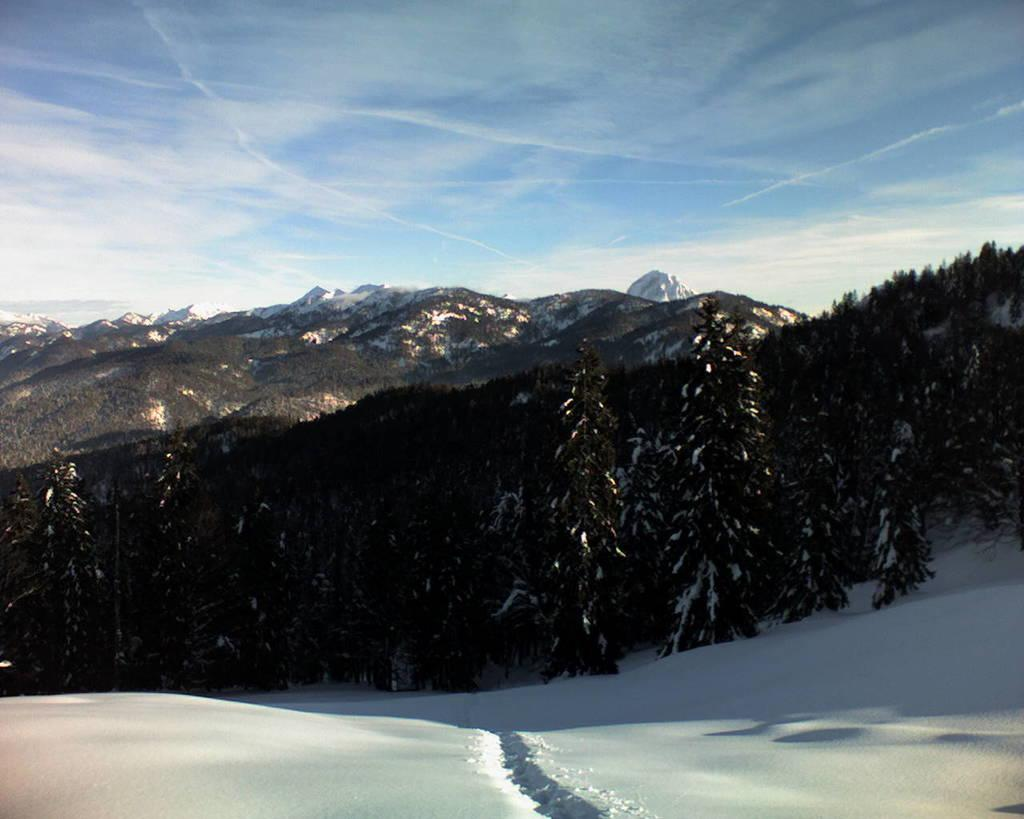What type of weather condition is depicted in the image? There is snow in the image, indicating a cold and wintry scene. What natural elements can be seen in the image? There are trees and mountains visible in the image. What is visible at the top of the image? The sky is visible at the top of the image. What type of sheet is covering the grass in the image? There is no sheet or grass present in the image; it features snow, trees, mountains, and a visible sky. 